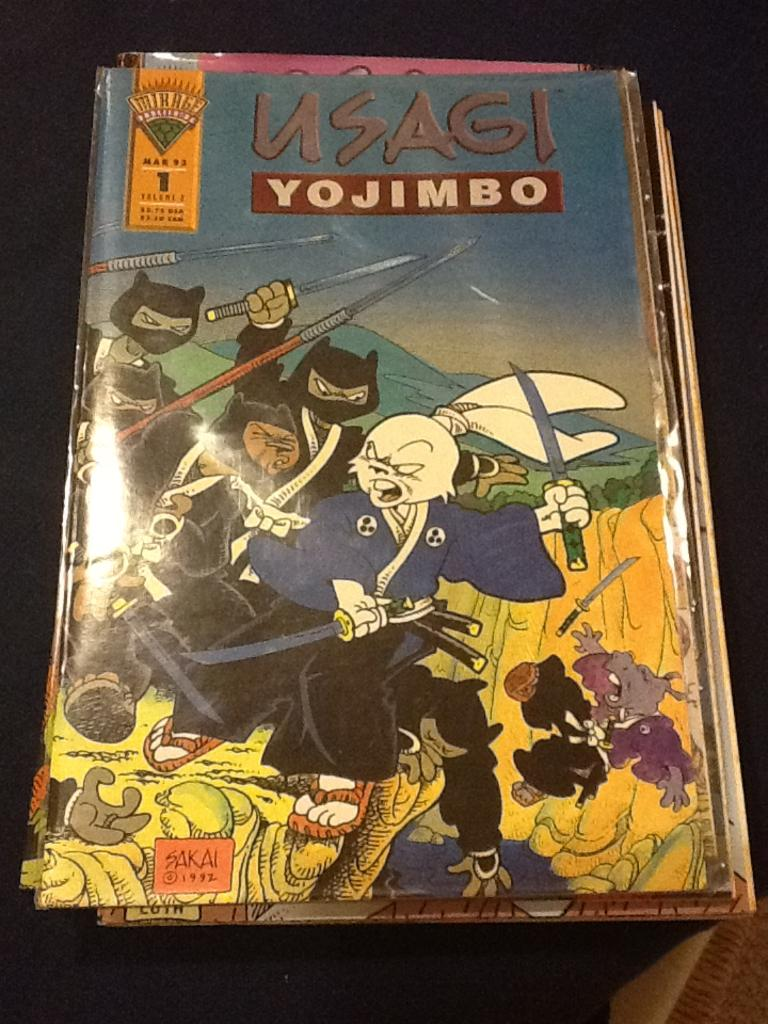<image>
Relay a brief, clear account of the picture shown. Usagi Yojimbo comic book with animals with swords 